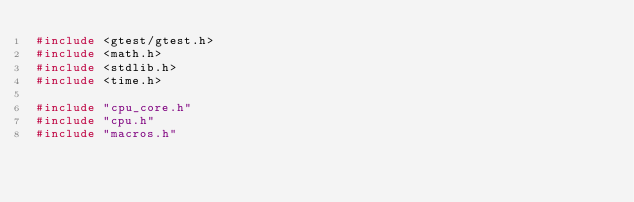Convert code to text. <code><loc_0><loc_0><loc_500><loc_500><_C++_>#include <gtest/gtest.h>
#include <math.h>
#include <stdlib.h>
#include <time.h>

#include "cpu_core.h"
#include "cpu.h"
#include "macros.h"</code> 